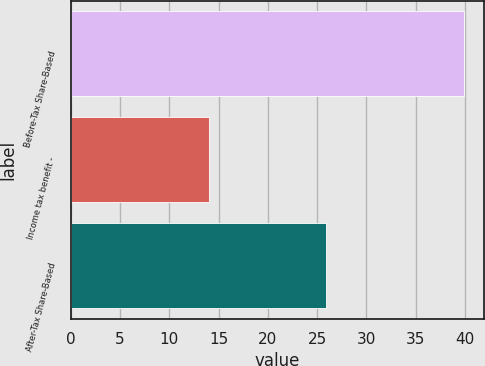<chart> <loc_0><loc_0><loc_500><loc_500><bar_chart><fcel>Before-Tax Share-Based<fcel>Income tax benefit -<fcel>After-Tax Share-Based<nl><fcel>39.9<fcel>14<fcel>25.9<nl></chart> 